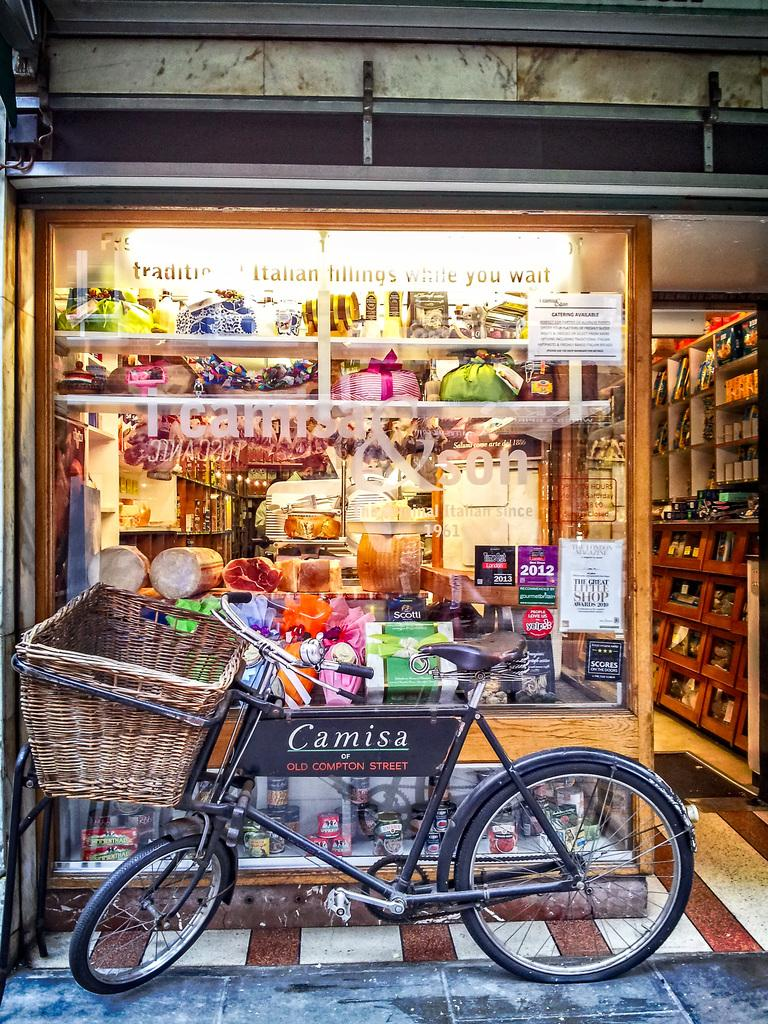<image>
Create a compact narrative representing the image presented. A store front with a bicycle in front with the sign "Camisa" on it. 